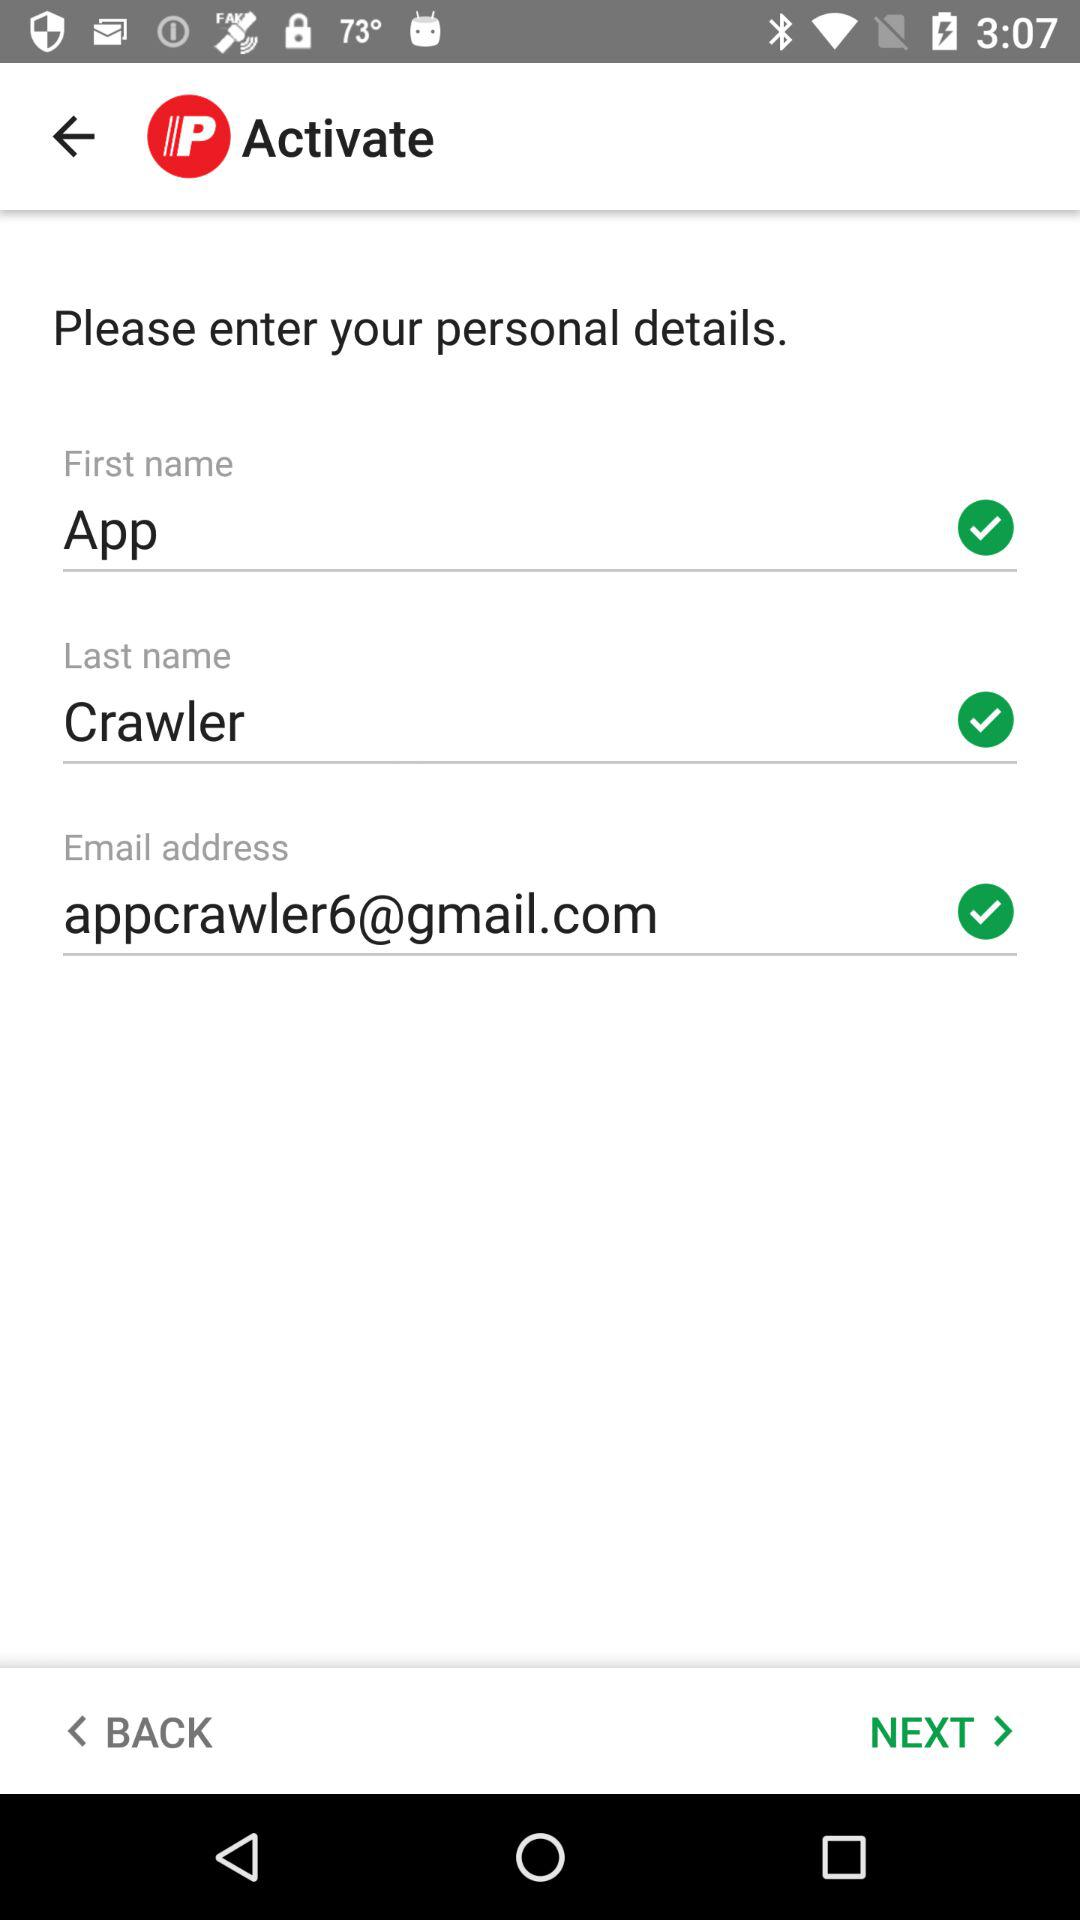What is the first name of the user? The first name of the user is App. 